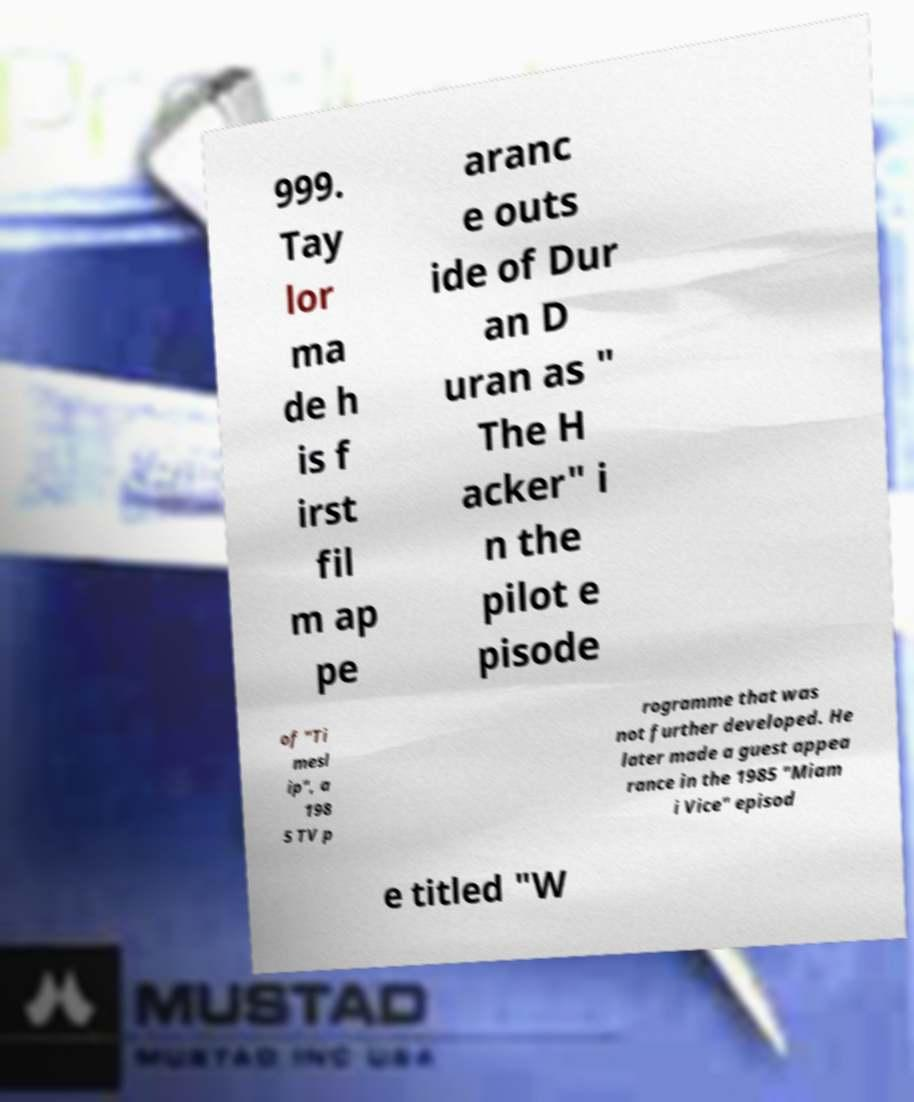There's text embedded in this image that I need extracted. Can you transcribe it verbatim? 999. Tay lor ma de h is f irst fil m ap pe aranc e outs ide of Dur an D uran as " The H acker" i n the pilot e pisode of "Ti mesl ip", a 198 5 TV p rogramme that was not further developed. He later made a guest appea rance in the 1985 "Miam i Vice" episod e titled "W 